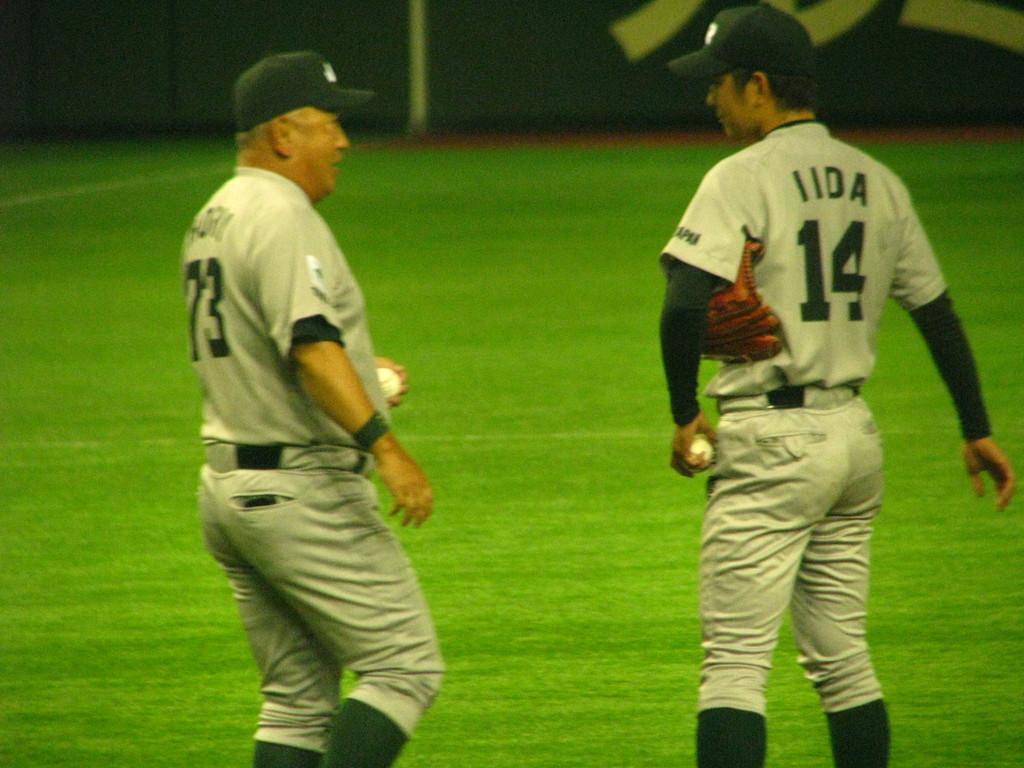What is the player on the rights number?
Your answer should be compact. 14. 